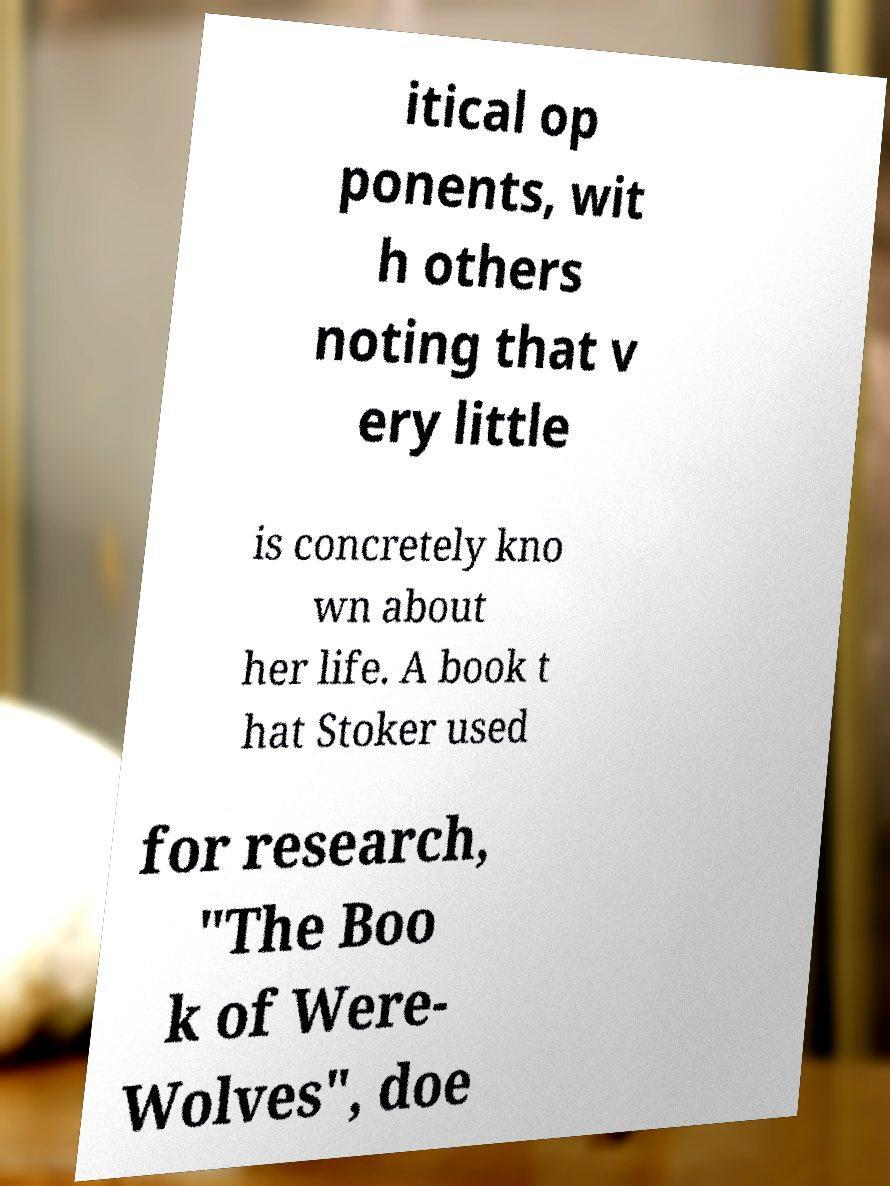Can you accurately transcribe the text from the provided image for me? itical op ponents, wit h others noting that v ery little is concretely kno wn about her life. A book t hat Stoker used for research, "The Boo k of Were- Wolves", doe 